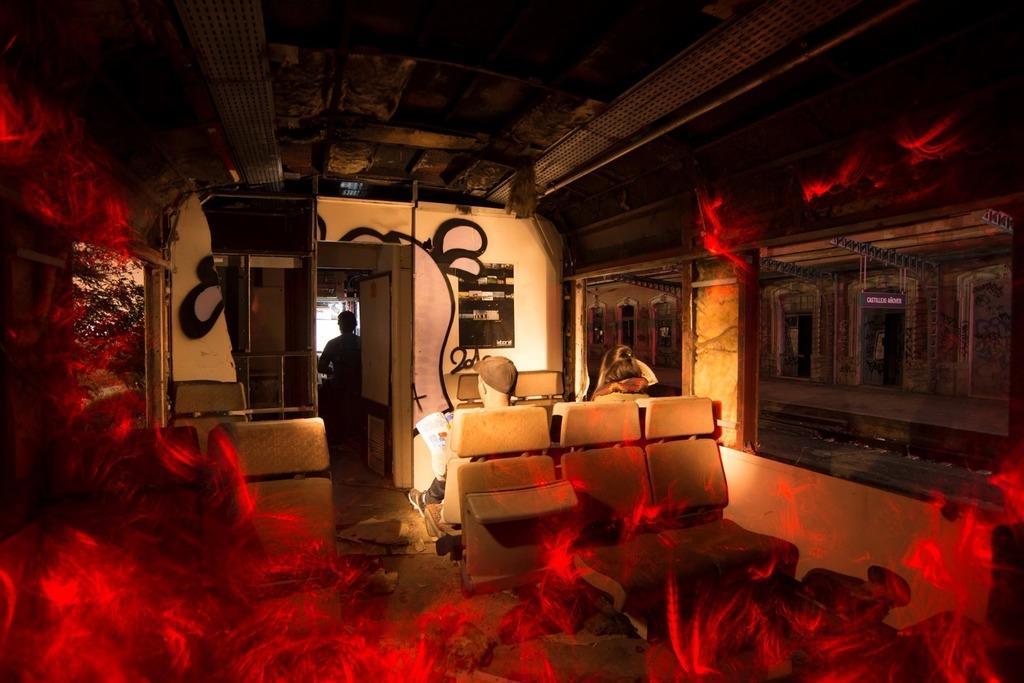Could you give a brief overview of what you see in this image? This is an edited picture. I can see two persons sitting on the seats, there is a person standing, there are windows and there is a platform. 